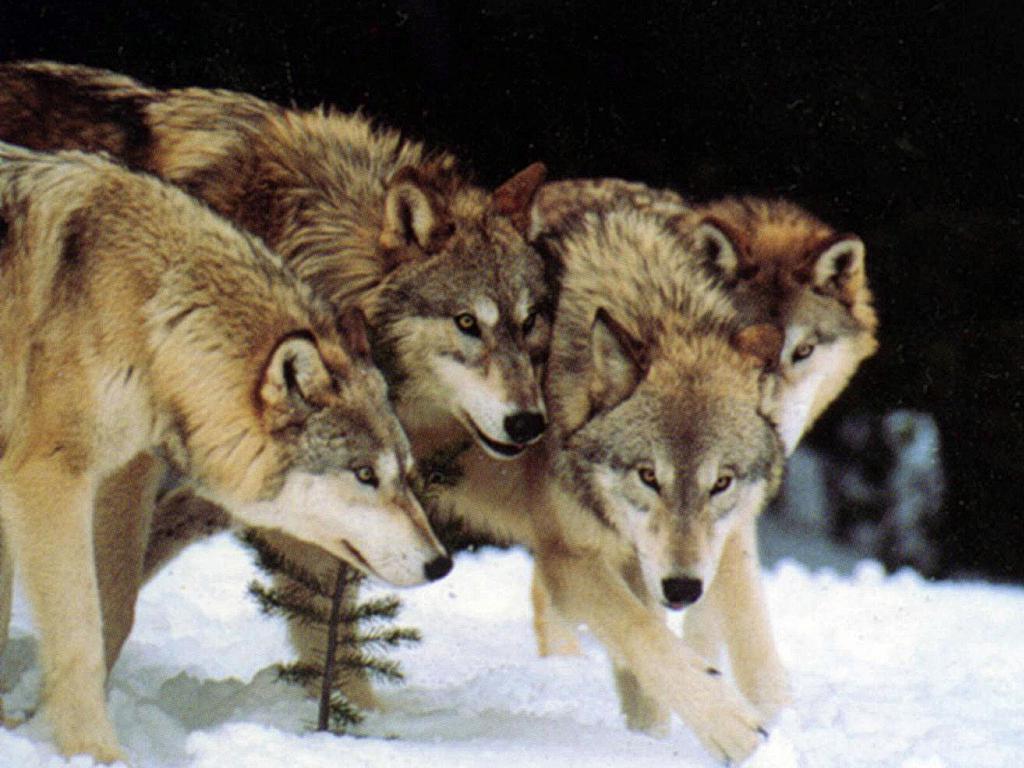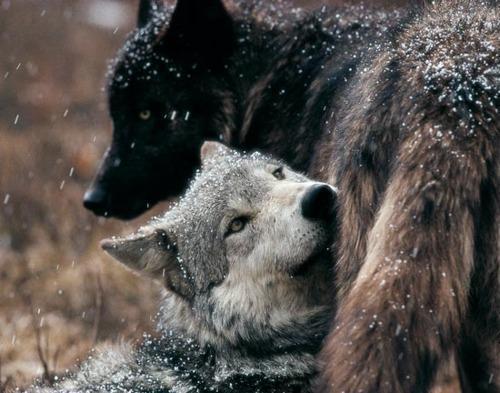The first image is the image on the left, the second image is the image on the right. Examine the images to the left and right. Is the description "The image on the right contains one wolf with a black colored head." accurate? Answer yes or no. Yes. The first image is the image on the left, the second image is the image on the right. For the images shown, is this caption "The image on the right contains exactly one black wolf" true? Answer yes or no. Yes. 